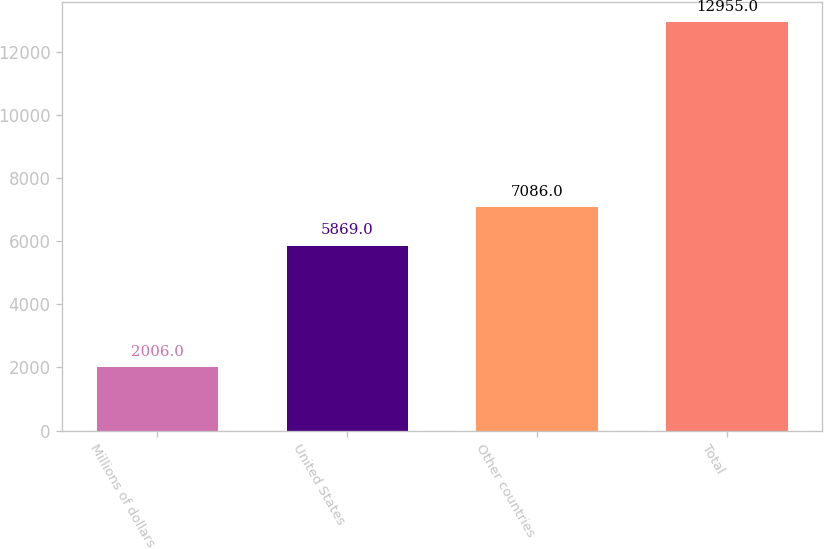<chart> <loc_0><loc_0><loc_500><loc_500><bar_chart><fcel>Millions of dollars<fcel>United States<fcel>Other countries<fcel>Total<nl><fcel>2006<fcel>5869<fcel>7086<fcel>12955<nl></chart> 